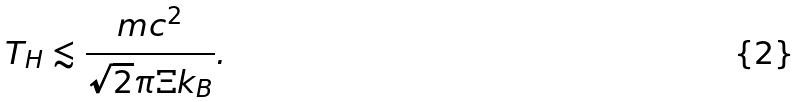<formula> <loc_0><loc_0><loc_500><loc_500>T _ { H } \lesssim \frac { m c ^ { 2 } } { \sqrt { 2 } \pi \Xi k _ { B } } .</formula> 